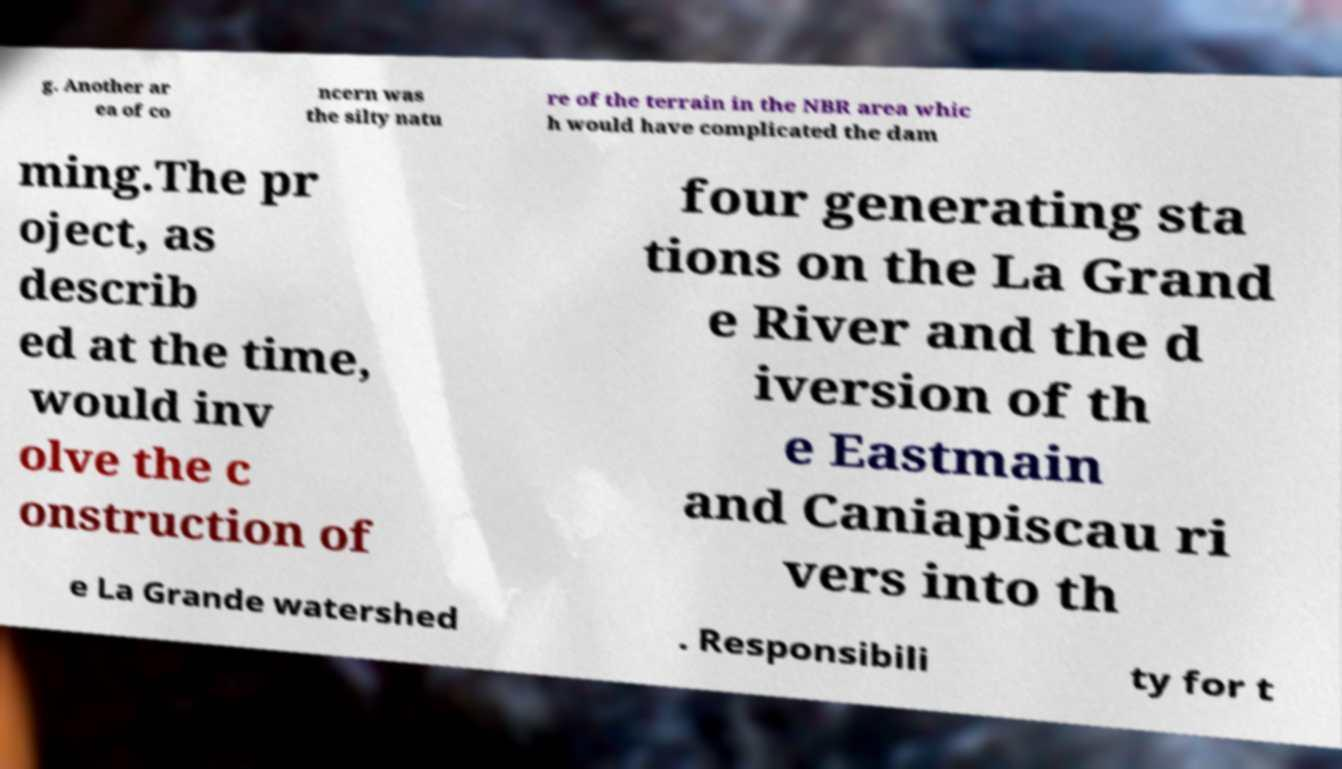There's text embedded in this image that I need extracted. Can you transcribe it verbatim? g. Another ar ea of co ncern was the silty natu re of the terrain in the NBR area whic h would have complicated the dam ming.The pr oject, as describ ed at the time, would inv olve the c onstruction of four generating sta tions on the La Grand e River and the d iversion of th e Eastmain and Caniapiscau ri vers into th e La Grande watershed . Responsibili ty for t 